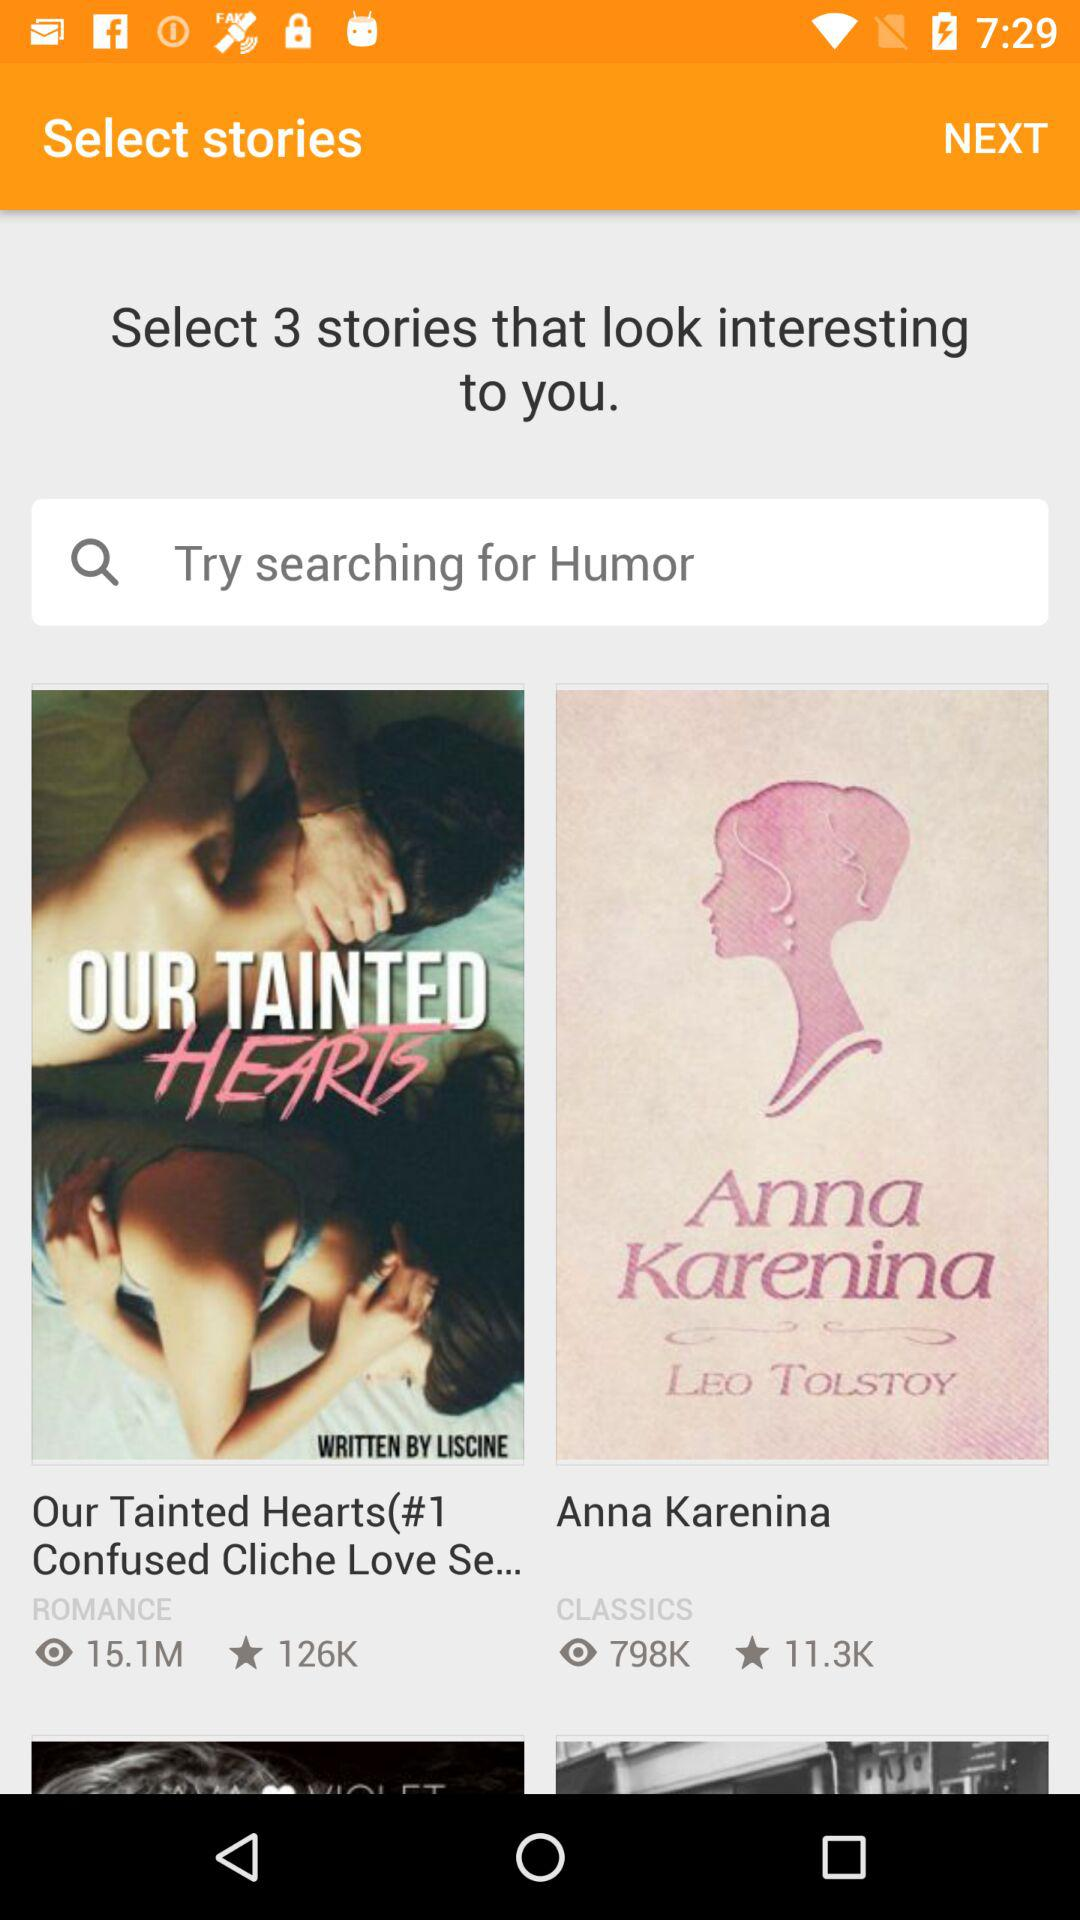How many people have viewed the story "Anna Karenina"? There are 798K people who have viewed the story. 